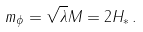Convert formula to latex. <formula><loc_0><loc_0><loc_500><loc_500>m _ { \phi } = \sqrt { \lambda } M = 2 H _ { * } \, .</formula> 